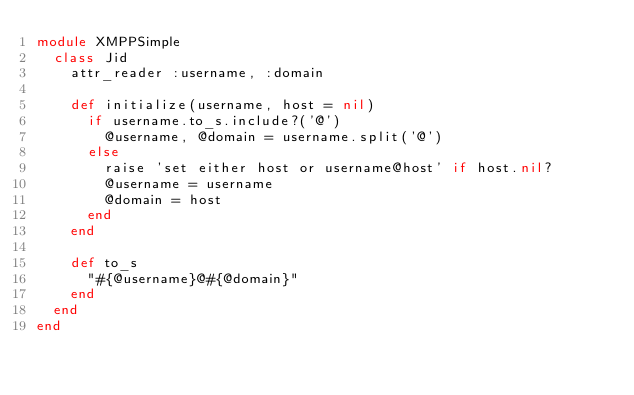<code> <loc_0><loc_0><loc_500><loc_500><_Ruby_>module XMPPSimple
  class Jid
    attr_reader :username, :domain

    def initialize(username, host = nil)
      if username.to_s.include?('@')
        @username, @domain = username.split('@')
      else
        raise 'set either host or username@host' if host.nil?
        @username = username
        @domain = host
      end
    end

    def to_s
      "#{@username}@#{@domain}"
    end
  end
end
</code> 